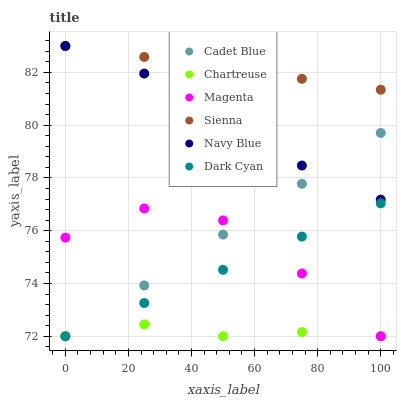Does Chartreuse have the minimum area under the curve?
Answer yes or no. Yes. Does Sienna have the maximum area under the curve?
Answer yes or no. Yes. Does Navy Blue have the minimum area under the curve?
Answer yes or no. No. Does Navy Blue have the maximum area under the curve?
Answer yes or no. No. Is Sienna the smoothest?
Answer yes or no. Yes. Is Magenta the roughest?
Answer yes or no. Yes. Is Navy Blue the smoothest?
Answer yes or no. No. Is Navy Blue the roughest?
Answer yes or no. No. Does Cadet Blue have the lowest value?
Answer yes or no. Yes. Does Navy Blue have the lowest value?
Answer yes or no. No. Does Sienna have the highest value?
Answer yes or no. Yes. Does Chartreuse have the highest value?
Answer yes or no. No. Is Chartreuse less than Sienna?
Answer yes or no. Yes. Is Navy Blue greater than Dark Cyan?
Answer yes or no. Yes. Does Sienna intersect Navy Blue?
Answer yes or no. Yes. Is Sienna less than Navy Blue?
Answer yes or no. No. Is Sienna greater than Navy Blue?
Answer yes or no. No. Does Chartreuse intersect Sienna?
Answer yes or no. No. 